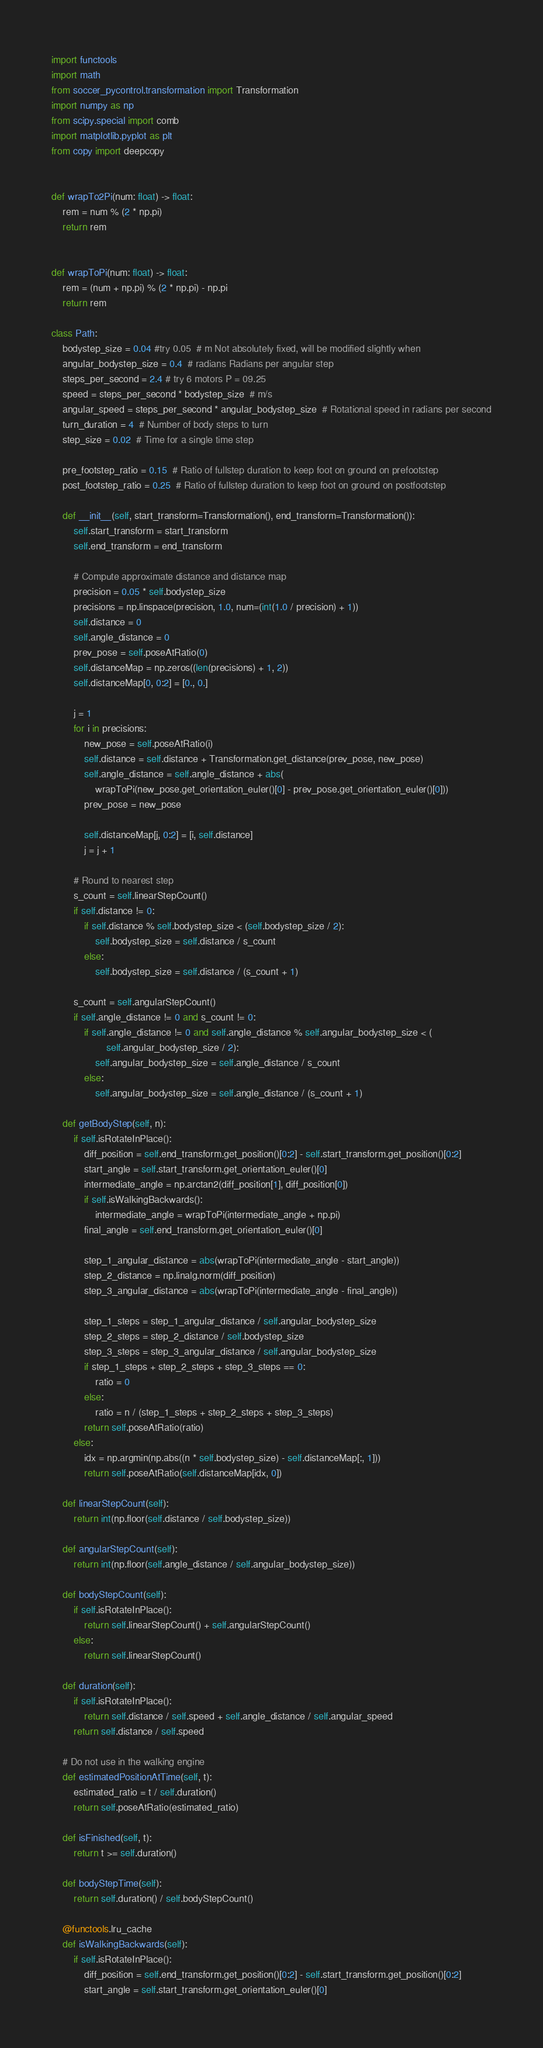<code> <loc_0><loc_0><loc_500><loc_500><_Python_>import functools
import math
from soccer_pycontrol.transformation import Transformation
import numpy as np
from scipy.special import comb
import matplotlib.pyplot as plt
from copy import deepcopy


def wrapTo2Pi(num: float) -> float:
    rem = num % (2 * np.pi)
    return rem


def wrapToPi(num: float) -> float:
    rem = (num + np.pi) % (2 * np.pi) - np.pi
    return rem

class Path:
    bodystep_size = 0.04 #try 0.05  # m Not absolutely fixed, will be modified slightly when
    angular_bodystep_size = 0.4  # radians Radians per angular step
    steps_per_second = 2.4 # try 6 motors P = 09.25
    speed = steps_per_second * bodystep_size  # m/s
    angular_speed = steps_per_second * angular_bodystep_size  # Rotational speed in radians per second
    turn_duration = 4  # Number of body steps to turn
    step_size = 0.02  # Time for a single time step

    pre_footstep_ratio = 0.15  # Ratio of fullstep duration to keep foot on ground on prefootstep
    post_footstep_ratio = 0.25  # Ratio of fullstep duration to keep foot on ground on postfootstep

    def __init__(self, start_transform=Transformation(), end_transform=Transformation()):
        self.start_transform = start_transform
        self.end_transform = end_transform

        # Compute approximate distance and distance map
        precision = 0.05 * self.bodystep_size
        precisions = np.linspace(precision, 1.0, num=(int(1.0 / precision) + 1))
        self.distance = 0
        self.angle_distance = 0
        prev_pose = self.poseAtRatio(0)
        self.distanceMap = np.zeros((len(precisions) + 1, 2))
        self.distanceMap[0, 0:2] = [0., 0.]

        j = 1
        for i in precisions:
            new_pose = self.poseAtRatio(i)
            self.distance = self.distance + Transformation.get_distance(prev_pose, new_pose)
            self.angle_distance = self.angle_distance + abs(
                wrapToPi(new_pose.get_orientation_euler()[0] - prev_pose.get_orientation_euler()[0]))
            prev_pose = new_pose

            self.distanceMap[j, 0:2] = [i, self.distance]
            j = j + 1

        # Round to nearest step
        s_count = self.linearStepCount()
        if self.distance != 0:
            if self.distance % self.bodystep_size < (self.bodystep_size / 2):
                self.bodystep_size = self.distance / s_count
            else:
                self.bodystep_size = self.distance / (s_count + 1)

        s_count = self.angularStepCount()
        if self.angle_distance != 0 and s_count != 0:
            if self.angle_distance != 0 and self.angle_distance % self.angular_bodystep_size < (
                    self.angular_bodystep_size / 2):
                self.angular_bodystep_size = self.angle_distance / s_count
            else:
                self.angular_bodystep_size = self.angle_distance / (s_count + 1)

    def getBodyStep(self, n):
        if self.isRotateInPlace():
            diff_position = self.end_transform.get_position()[0:2] - self.start_transform.get_position()[0:2]
            start_angle = self.start_transform.get_orientation_euler()[0]
            intermediate_angle = np.arctan2(diff_position[1], diff_position[0])
            if self.isWalkingBackwards():
                intermediate_angle = wrapToPi(intermediate_angle + np.pi)
            final_angle = self.end_transform.get_orientation_euler()[0]

            step_1_angular_distance = abs(wrapToPi(intermediate_angle - start_angle))
            step_2_distance = np.linalg.norm(diff_position)
            step_3_angular_distance = abs(wrapToPi(intermediate_angle - final_angle))

            step_1_steps = step_1_angular_distance / self.angular_bodystep_size
            step_2_steps = step_2_distance / self.bodystep_size
            step_3_steps = step_3_angular_distance / self.angular_bodystep_size
            if step_1_steps + step_2_steps + step_3_steps == 0:
                ratio = 0
            else:
                ratio = n / (step_1_steps + step_2_steps + step_3_steps)
            return self.poseAtRatio(ratio)
        else:
            idx = np.argmin(np.abs((n * self.bodystep_size) - self.distanceMap[:, 1]))
            return self.poseAtRatio(self.distanceMap[idx, 0])

    def linearStepCount(self):
        return int(np.floor(self.distance / self.bodystep_size))

    def angularStepCount(self):
        return int(np.floor(self.angle_distance / self.angular_bodystep_size))

    def bodyStepCount(self):
        if self.isRotateInPlace():
            return self.linearStepCount() + self.angularStepCount()
        else:
            return self.linearStepCount()

    def duration(self):
        if self.isRotateInPlace():
            return self.distance / self.speed + self.angle_distance / self.angular_speed
        return self.distance / self.speed

    # Do not use in the walking engine
    def estimatedPositionAtTime(self, t):
        estimated_ratio = t / self.duration()
        return self.poseAtRatio(estimated_ratio)

    def isFinished(self, t):
        return t >= self.duration()

    def bodyStepTime(self):
        return self.duration() / self.bodyStepCount()

    @functools.lru_cache
    def isWalkingBackwards(self):
        if self.isRotateInPlace():
            diff_position = self.end_transform.get_position()[0:2] - self.start_transform.get_position()[0:2]
            start_angle = self.start_transform.get_orientation_euler()[0]</code> 